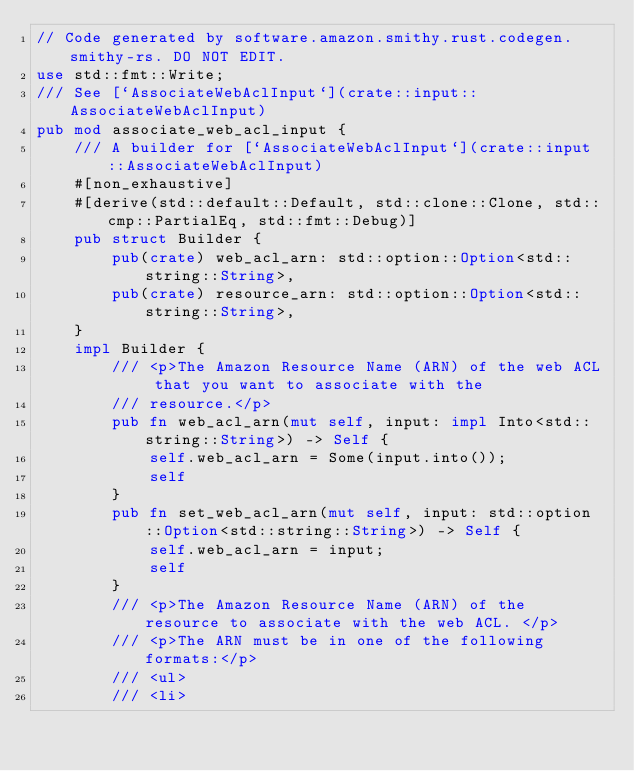<code> <loc_0><loc_0><loc_500><loc_500><_Rust_>// Code generated by software.amazon.smithy.rust.codegen.smithy-rs. DO NOT EDIT.
use std::fmt::Write;
/// See [`AssociateWebAclInput`](crate::input::AssociateWebAclInput)
pub mod associate_web_acl_input {
    /// A builder for [`AssociateWebAclInput`](crate::input::AssociateWebAclInput)
    #[non_exhaustive]
    #[derive(std::default::Default, std::clone::Clone, std::cmp::PartialEq, std::fmt::Debug)]
    pub struct Builder {
        pub(crate) web_acl_arn: std::option::Option<std::string::String>,
        pub(crate) resource_arn: std::option::Option<std::string::String>,
    }
    impl Builder {
        /// <p>The Amazon Resource Name (ARN) of the web ACL that you want to associate with the
        /// resource.</p>
        pub fn web_acl_arn(mut self, input: impl Into<std::string::String>) -> Self {
            self.web_acl_arn = Some(input.into());
            self
        }
        pub fn set_web_acl_arn(mut self, input: std::option::Option<std::string::String>) -> Self {
            self.web_acl_arn = input;
            self
        }
        /// <p>The Amazon Resource Name (ARN) of the resource to associate with the web ACL. </p>
        /// <p>The ARN must be in one of the following formats:</p>
        /// <ul>
        /// <li></code> 